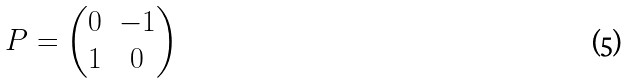<formula> <loc_0><loc_0><loc_500><loc_500>P = \begin{pmatrix} 0 & - 1 \\ 1 & 0 \end{pmatrix}</formula> 